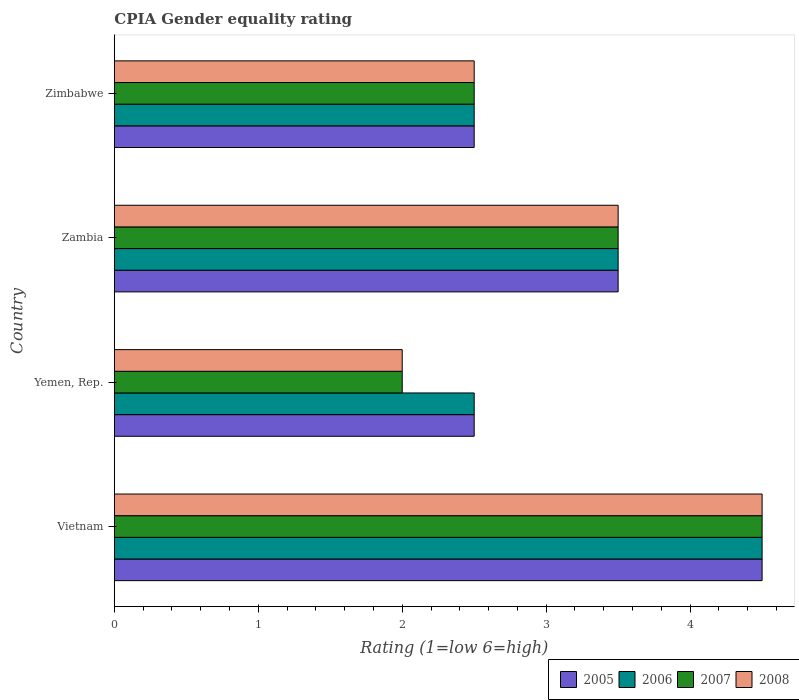How many different coloured bars are there?
Provide a succinct answer. 4. How many groups of bars are there?
Your answer should be compact. 4. Are the number of bars per tick equal to the number of legend labels?
Give a very brief answer. Yes. How many bars are there on the 3rd tick from the top?
Provide a succinct answer. 4. What is the label of the 3rd group of bars from the top?
Your answer should be very brief. Yemen, Rep. What is the CPIA rating in 2007 in Zambia?
Provide a short and direct response. 3.5. In which country was the CPIA rating in 2005 maximum?
Your answer should be very brief. Vietnam. In which country was the CPIA rating in 2007 minimum?
Your answer should be compact. Yemen, Rep. What is the difference between the CPIA rating in 2005 in Yemen, Rep. and the CPIA rating in 2007 in Vietnam?
Your response must be concise. -2. What is the average CPIA rating in 2008 per country?
Provide a short and direct response. 3.12. What is the difference between the CPIA rating in 2007 and CPIA rating in 2008 in Yemen, Rep.?
Your answer should be very brief. 0. What is the ratio of the CPIA rating in 2007 in Vietnam to that in Yemen, Rep.?
Ensure brevity in your answer.  2.25. What is the difference between the highest and the second highest CPIA rating in 2006?
Offer a very short reply. 1. Is the sum of the CPIA rating in 2007 in Yemen, Rep. and Zimbabwe greater than the maximum CPIA rating in 2008 across all countries?
Your answer should be very brief. No. Is it the case that in every country, the sum of the CPIA rating in 2007 and CPIA rating in 2008 is greater than the sum of CPIA rating in 2006 and CPIA rating in 2005?
Give a very brief answer. No. What does the 2nd bar from the bottom in Zimbabwe represents?
Keep it short and to the point. 2006. Is it the case that in every country, the sum of the CPIA rating in 2007 and CPIA rating in 2005 is greater than the CPIA rating in 2008?
Make the answer very short. Yes. Are all the bars in the graph horizontal?
Make the answer very short. Yes. What is the difference between two consecutive major ticks on the X-axis?
Your response must be concise. 1. Does the graph contain any zero values?
Your answer should be compact. No. How many legend labels are there?
Make the answer very short. 4. How are the legend labels stacked?
Provide a succinct answer. Horizontal. What is the title of the graph?
Your answer should be compact. CPIA Gender equality rating. What is the label or title of the X-axis?
Your answer should be compact. Rating (1=low 6=high). What is the label or title of the Y-axis?
Your answer should be very brief. Country. What is the Rating (1=low 6=high) of 2005 in Vietnam?
Your response must be concise. 4.5. What is the Rating (1=low 6=high) of 2007 in Vietnam?
Your response must be concise. 4.5. What is the Rating (1=low 6=high) of 2006 in Yemen, Rep.?
Provide a succinct answer. 2.5. What is the Rating (1=low 6=high) in 2008 in Yemen, Rep.?
Your response must be concise. 2. What is the Rating (1=low 6=high) of 2007 in Zambia?
Keep it short and to the point. 3.5. What is the Rating (1=low 6=high) in 2008 in Zambia?
Give a very brief answer. 3.5. What is the Rating (1=low 6=high) of 2005 in Zimbabwe?
Make the answer very short. 2.5. What is the Rating (1=low 6=high) in 2006 in Zimbabwe?
Provide a short and direct response. 2.5. What is the Rating (1=low 6=high) in 2007 in Zimbabwe?
Give a very brief answer. 2.5. What is the Rating (1=low 6=high) in 2008 in Zimbabwe?
Make the answer very short. 2.5. Across all countries, what is the maximum Rating (1=low 6=high) of 2005?
Your response must be concise. 4.5. Across all countries, what is the maximum Rating (1=low 6=high) in 2006?
Offer a very short reply. 4.5. Across all countries, what is the maximum Rating (1=low 6=high) in 2007?
Make the answer very short. 4.5. Across all countries, what is the maximum Rating (1=low 6=high) in 2008?
Offer a terse response. 4.5. Across all countries, what is the minimum Rating (1=low 6=high) of 2008?
Ensure brevity in your answer.  2. What is the total Rating (1=low 6=high) in 2005 in the graph?
Provide a short and direct response. 13. What is the total Rating (1=low 6=high) of 2007 in the graph?
Your answer should be compact. 12.5. What is the total Rating (1=low 6=high) of 2008 in the graph?
Ensure brevity in your answer.  12.5. What is the difference between the Rating (1=low 6=high) in 2005 in Vietnam and that in Yemen, Rep.?
Make the answer very short. 2. What is the difference between the Rating (1=low 6=high) in 2006 in Vietnam and that in Yemen, Rep.?
Ensure brevity in your answer.  2. What is the difference between the Rating (1=low 6=high) in 2008 in Vietnam and that in Yemen, Rep.?
Offer a very short reply. 2.5. What is the difference between the Rating (1=low 6=high) of 2005 in Vietnam and that in Zambia?
Keep it short and to the point. 1. What is the difference between the Rating (1=low 6=high) in 2006 in Vietnam and that in Zambia?
Keep it short and to the point. 1. What is the difference between the Rating (1=low 6=high) in 2006 in Vietnam and that in Zimbabwe?
Offer a very short reply. 2. What is the difference between the Rating (1=low 6=high) in 2007 in Vietnam and that in Zimbabwe?
Keep it short and to the point. 2. What is the difference between the Rating (1=low 6=high) in 2006 in Yemen, Rep. and that in Zambia?
Keep it short and to the point. -1. What is the difference between the Rating (1=low 6=high) of 2005 in Yemen, Rep. and that in Zimbabwe?
Your answer should be very brief. 0. What is the difference between the Rating (1=low 6=high) in 2006 in Yemen, Rep. and that in Zimbabwe?
Give a very brief answer. 0. What is the difference between the Rating (1=low 6=high) in 2008 in Yemen, Rep. and that in Zimbabwe?
Make the answer very short. -0.5. What is the difference between the Rating (1=low 6=high) in 2007 in Zambia and that in Zimbabwe?
Keep it short and to the point. 1. What is the difference between the Rating (1=low 6=high) of 2008 in Zambia and that in Zimbabwe?
Offer a very short reply. 1. What is the difference between the Rating (1=low 6=high) in 2005 in Vietnam and the Rating (1=low 6=high) in 2008 in Yemen, Rep.?
Ensure brevity in your answer.  2.5. What is the difference between the Rating (1=low 6=high) in 2005 in Vietnam and the Rating (1=low 6=high) in 2006 in Zambia?
Keep it short and to the point. 1. What is the difference between the Rating (1=low 6=high) of 2006 in Vietnam and the Rating (1=low 6=high) of 2008 in Zambia?
Keep it short and to the point. 1. What is the difference between the Rating (1=low 6=high) of 2005 in Vietnam and the Rating (1=low 6=high) of 2006 in Zimbabwe?
Give a very brief answer. 2. What is the difference between the Rating (1=low 6=high) in 2005 in Vietnam and the Rating (1=low 6=high) in 2007 in Zimbabwe?
Offer a very short reply. 2. What is the difference between the Rating (1=low 6=high) in 2005 in Vietnam and the Rating (1=low 6=high) in 2008 in Zimbabwe?
Provide a short and direct response. 2. What is the difference between the Rating (1=low 6=high) of 2006 in Vietnam and the Rating (1=low 6=high) of 2007 in Zimbabwe?
Keep it short and to the point. 2. What is the difference between the Rating (1=low 6=high) of 2006 in Vietnam and the Rating (1=low 6=high) of 2008 in Zimbabwe?
Your response must be concise. 2. What is the difference between the Rating (1=low 6=high) in 2007 in Vietnam and the Rating (1=low 6=high) in 2008 in Zimbabwe?
Your answer should be very brief. 2. What is the difference between the Rating (1=low 6=high) of 2005 in Yemen, Rep. and the Rating (1=low 6=high) of 2008 in Zambia?
Your answer should be compact. -1. What is the difference between the Rating (1=low 6=high) in 2006 in Yemen, Rep. and the Rating (1=low 6=high) in 2007 in Zambia?
Provide a succinct answer. -1. What is the difference between the Rating (1=low 6=high) of 2006 in Yemen, Rep. and the Rating (1=low 6=high) of 2008 in Zambia?
Offer a very short reply. -1. What is the difference between the Rating (1=low 6=high) in 2007 in Yemen, Rep. and the Rating (1=low 6=high) in 2008 in Zambia?
Offer a terse response. -1.5. What is the difference between the Rating (1=low 6=high) of 2005 in Yemen, Rep. and the Rating (1=low 6=high) of 2006 in Zimbabwe?
Your answer should be very brief. 0. What is the difference between the Rating (1=low 6=high) of 2005 in Yemen, Rep. and the Rating (1=low 6=high) of 2007 in Zimbabwe?
Your answer should be compact. 0. What is the difference between the Rating (1=low 6=high) in 2005 in Yemen, Rep. and the Rating (1=low 6=high) in 2008 in Zimbabwe?
Your answer should be very brief. 0. What is the difference between the Rating (1=low 6=high) in 2006 in Yemen, Rep. and the Rating (1=low 6=high) in 2007 in Zimbabwe?
Your response must be concise. 0. What is the difference between the Rating (1=low 6=high) in 2006 in Yemen, Rep. and the Rating (1=low 6=high) in 2008 in Zimbabwe?
Provide a short and direct response. 0. What is the difference between the Rating (1=low 6=high) of 2006 in Zambia and the Rating (1=low 6=high) of 2007 in Zimbabwe?
Your answer should be very brief. 1. What is the average Rating (1=low 6=high) in 2006 per country?
Ensure brevity in your answer.  3.25. What is the average Rating (1=low 6=high) of 2007 per country?
Make the answer very short. 3.12. What is the average Rating (1=low 6=high) in 2008 per country?
Give a very brief answer. 3.12. What is the difference between the Rating (1=low 6=high) in 2005 and Rating (1=low 6=high) in 2006 in Vietnam?
Provide a short and direct response. 0. What is the difference between the Rating (1=low 6=high) of 2006 and Rating (1=low 6=high) of 2007 in Vietnam?
Give a very brief answer. 0. What is the difference between the Rating (1=low 6=high) in 2006 and Rating (1=low 6=high) in 2008 in Vietnam?
Give a very brief answer. 0. What is the difference between the Rating (1=low 6=high) of 2007 and Rating (1=low 6=high) of 2008 in Vietnam?
Offer a very short reply. 0. What is the difference between the Rating (1=low 6=high) of 2005 and Rating (1=low 6=high) of 2008 in Yemen, Rep.?
Provide a succinct answer. 0.5. What is the difference between the Rating (1=low 6=high) in 2006 and Rating (1=low 6=high) in 2007 in Yemen, Rep.?
Keep it short and to the point. 0.5. What is the difference between the Rating (1=low 6=high) of 2006 and Rating (1=low 6=high) of 2008 in Yemen, Rep.?
Provide a succinct answer. 0.5. What is the difference between the Rating (1=low 6=high) in 2005 and Rating (1=low 6=high) in 2006 in Zambia?
Give a very brief answer. 0. What is the difference between the Rating (1=low 6=high) of 2006 and Rating (1=low 6=high) of 2007 in Zambia?
Keep it short and to the point. 0. What is the difference between the Rating (1=low 6=high) of 2006 and Rating (1=low 6=high) of 2008 in Zambia?
Offer a very short reply. 0. What is the difference between the Rating (1=low 6=high) of 2007 and Rating (1=low 6=high) of 2008 in Zambia?
Provide a succinct answer. 0. What is the difference between the Rating (1=low 6=high) of 2005 and Rating (1=low 6=high) of 2006 in Zimbabwe?
Keep it short and to the point. 0. What is the difference between the Rating (1=low 6=high) of 2005 and Rating (1=low 6=high) of 2007 in Zimbabwe?
Offer a very short reply. 0. What is the difference between the Rating (1=low 6=high) of 2005 and Rating (1=low 6=high) of 2008 in Zimbabwe?
Provide a short and direct response. 0. What is the difference between the Rating (1=low 6=high) of 2006 and Rating (1=low 6=high) of 2008 in Zimbabwe?
Offer a very short reply. 0. What is the ratio of the Rating (1=low 6=high) of 2006 in Vietnam to that in Yemen, Rep.?
Give a very brief answer. 1.8. What is the ratio of the Rating (1=low 6=high) of 2007 in Vietnam to that in Yemen, Rep.?
Ensure brevity in your answer.  2.25. What is the ratio of the Rating (1=low 6=high) of 2008 in Vietnam to that in Yemen, Rep.?
Make the answer very short. 2.25. What is the ratio of the Rating (1=low 6=high) of 2006 in Vietnam to that in Zambia?
Offer a very short reply. 1.29. What is the ratio of the Rating (1=low 6=high) of 2008 in Vietnam to that in Zambia?
Provide a short and direct response. 1.29. What is the ratio of the Rating (1=low 6=high) of 2005 in Vietnam to that in Zimbabwe?
Provide a succinct answer. 1.8. What is the ratio of the Rating (1=low 6=high) of 2006 in Vietnam to that in Zimbabwe?
Offer a very short reply. 1.8. What is the ratio of the Rating (1=low 6=high) in 2008 in Vietnam to that in Zimbabwe?
Provide a succinct answer. 1.8. What is the ratio of the Rating (1=low 6=high) of 2005 in Yemen, Rep. to that in Zambia?
Keep it short and to the point. 0.71. What is the ratio of the Rating (1=low 6=high) of 2006 in Yemen, Rep. to that in Zambia?
Offer a very short reply. 0.71. What is the ratio of the Rating (1=low 6=high) in 2005 in Yemen, Rep. to that in Zimbabwe?
Give a very brief answer. 1. What is the ratio of the Rating (1=low 6=high) in 2008 in Yemen, Rep. to that in Zimbabwe?
Ensure brevity in your answer.  0.8. What is the ratio of the Rating (1=low 6=high) of 2005 in Zambia to that in Zimbabwe?
Your response must be concise. 1.4. What is the ratio of the Rating (1=low 6=high) in 2006 in Zambia to that in Zimbabwe?
Offer a very short reply. 1.4. What is the ratio of the Rating (1=low 6=high) in 2007 in Zambia to that in Zimbabwe?
Give a very brief answer. 1.4. What is the difference between the highest and the second highest Rating (1=low 6=high) of 2008?
Provide a short and direct response. 1. 